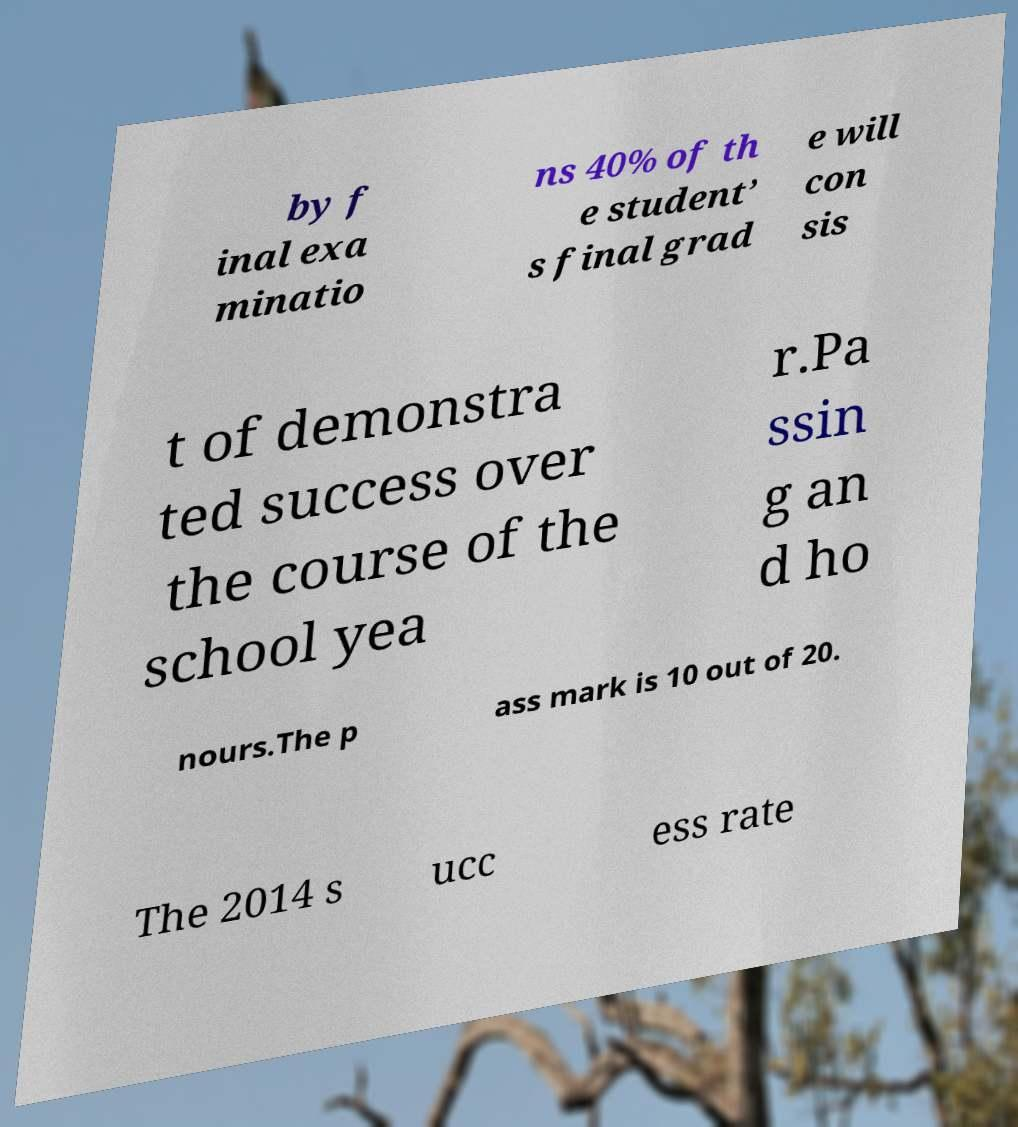What messages or text are displayed in this image? I need them in a readable, typed format. by f inal exa minatio ns 40% of th e student’ s final grad e will con sis t of demonstra ted success over the course of the school yea r.Pa ssin g an d ho nours.The p ass mark is 10 out of 20. The 2014 s ucc ess rate 